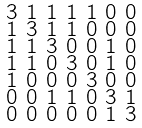Convert formula to latex. <formula><loc_0><loc_0><loc_500><loc_500>\begin{smallmatrix} 3 & 1 & 1 & 1 & 1 & 0 & 0 \\ 1 & 3 & 1 & 1 & 0 & 0 & 0 \\ 1 & 1 & 3 & 0 & 0 & 1 & 0 \\ 1 & 1 & 0 & 3 & 0 & 1 & 0 \\ 1 & 0 & 0 & 0 & 3 & 0 & 0 \\ 0 & 0 & 1 & 1 & 0 & 3 & 1 \\ 0 & 0 & 0 & 0 & 0 & 1 & 3 \end{smallmatrix}</formula> 